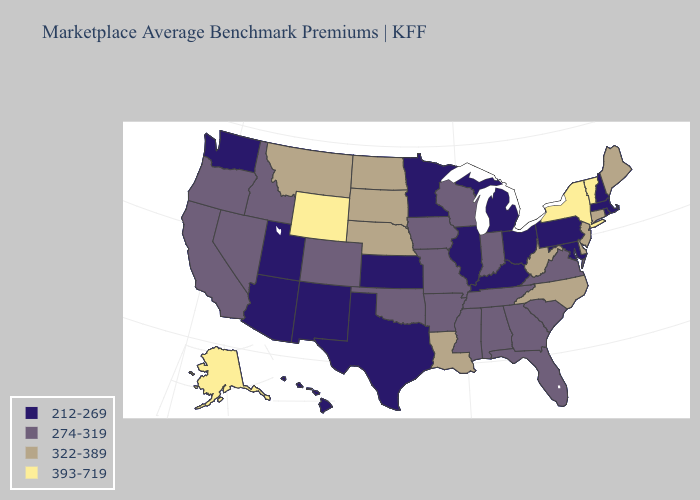Name the states that have a value in the range 212-269?
Answer briefly. Arizona, Hawaii, Illinois, Kansas, Kentucky, Maryland, Massachusetts, Michigan, Minnesota, New Hampshire, New Mexico, Ohio, Pennsylvania, Rhode Island, Texas, Utah, Washington. Among the states that border Utah , does Wyoming have the lowest value?
Give a very brief answer. No. Does Alaska have the highest value in the USA?
Write a very short answer. Yes. Name the states that have a value in the range 393-719?
Quick response, please. Alaska, New York, Vermont, Wyoming. How many symbols are there in the legend?
Short answer required. 4. Which states have the highest value in the USA?
Write a very short answer. Alaska, New York, Vermont, Wyoming. Name the states that have a value in the range 322-389?
Give a very brief answer. Connecticut, Delaware, Louisiana, Maine, Montana, Nebraska, New Jersey, North Carolina, North Dakota, South Dakota, West Virginia. Name the states that have a value in the range 274-319?
Be succinct. Alabama, Arkansas, California, Colorado, Florida, Georgia, Idaho, Indiana, Iowa, Mississippi, Missouri, Nevada, Oklahoma, Oregon, South Carolina, Tennessee, Virginia, Wisconsin. Does Montana have a lower value than Wyoming?
Be succinct. Yes. Among the states that border Indiana , which have the lowest value?
Concise answer only. Illinois, Kentucky, Michigan, Ohio. Name the states that have a value in the range 393-719?
Quick response, please. Alaska, New York, Vermont, Wyoming. Name the states that have a value in the range 212-269?
Keep it brief. Arizona, Hawaii, Illinois, Kansas, Kentucky, Maryland, Massachusetts, Michigan, Minnesota, New Hampshire, New Mexico, Ohio, Pennsylvania, Rhode Island, Texas, Utah, Washington. Which states have the highest value in the USA?
Concise answer only. Alaska, New York, Vermont, Wyoming. What is the value of Minnesota?
Short answer required. 212-269. Name the states that have a value in the range 393-719?
Be succinct. Alaska, New York, Vermont, Wyoming. 